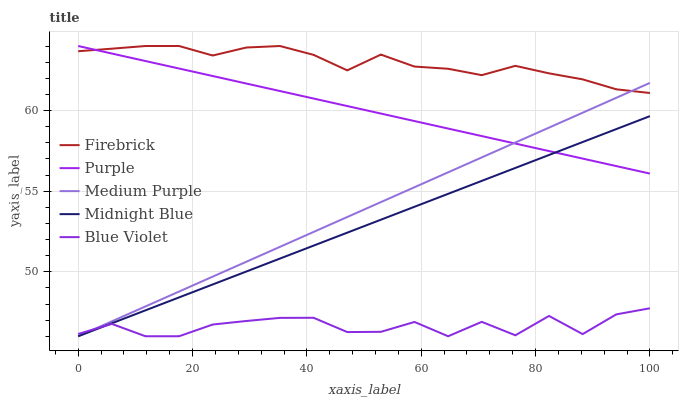Does Blue Violet have the minimum area under the curve?
Answer yes or no. Yes. Does Firebrick have the maximum area under the curve?
Answer yes or no. Yes. Does Medium Purple have the minimum area under the curve?
Answer yes or no. No. Does Medium Purple have the maximum area under the curve?
Answer yes or no. No. Is Medium Purple the smoothest?
Answer yes or no. Yes. Is Blue Violet the roughest?
Answer yes or no. Yes. Is Firebrick the smoothest?
Answer yes or no. No. Is Firebrick the roughest?
Answer yes or no. No. Does Medium Purple have the lowest value?
Answer yes or no. Yes. Does Firebrick have the lowest value?
Answer yes or no. No. Does Firebrick have the highest value?
Answer yes or no. Yes. Does Medium Purple have the highest value?
Answer yes or no. No. Is Midnight Blue less than Firebrick?
Answer yes or no. Yes. Is Firebrick greater than Blue Violet?
Answer yes or no. Yes. Does Blue Violet intersect Medium Purple?
Answer yes or no. Yes. Is Blue Violet less than Medium Purple?
Answer yes or no. No. Is Blue Violet greater than Medium Purple?
Answer yes or no. No. Does Midnight Blue intersect Firebrick?
Answer yes or no. No. 